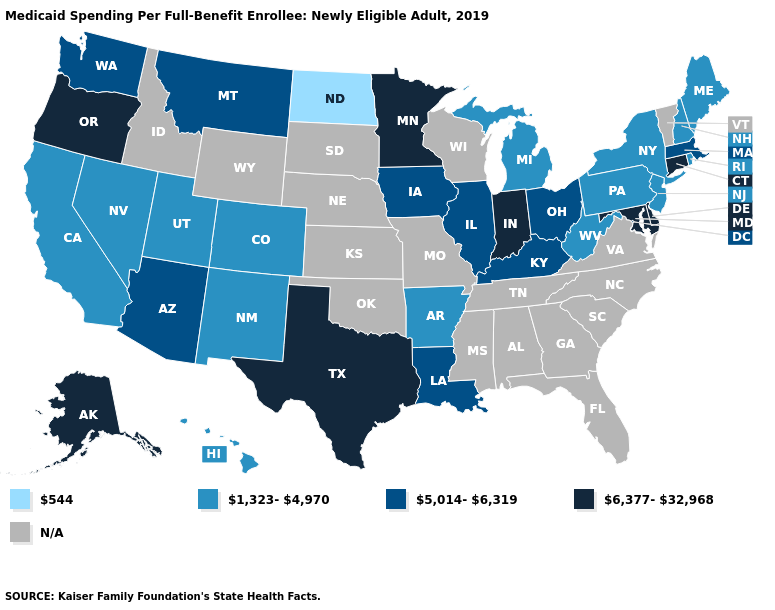Among the states that border Massachusetts , does New York have the highest value?
Answer briefly. No. Among the states that border New York , does Pennsylvania have the lowest value?
Be succinct. Yes. How many symbols are there in the legend?
Be succinct. 5. What is the value of Texas?
Concise answer only. 6,377-32,968. Name the states that have a value in the range 5,014-6,319?
Keep it brief. Arizona, Illinois, Iowa, Kentucky, Louisiana, Massachusetts, Montana, Ohio, Washington. Is the legend a continuous bar?
Write a very short answer. No. Which states hav the highest value in the West?
Answer briefly. Alaska, Oregon. What is the value of New Mexico?
Give a very brief answer. 1,323-4,970. Does Connecticut have the highest value in the Northeast?
Give a very brief answer. Yes. What is the highest value in the Northeast ?
Answer briefly. 6,377-32,968. Does Connecticut have the highest value in the USA?
Give a very brief answer. Yes. What is the lowest value in the South?
Keep it brief. 1,323-4,970. 